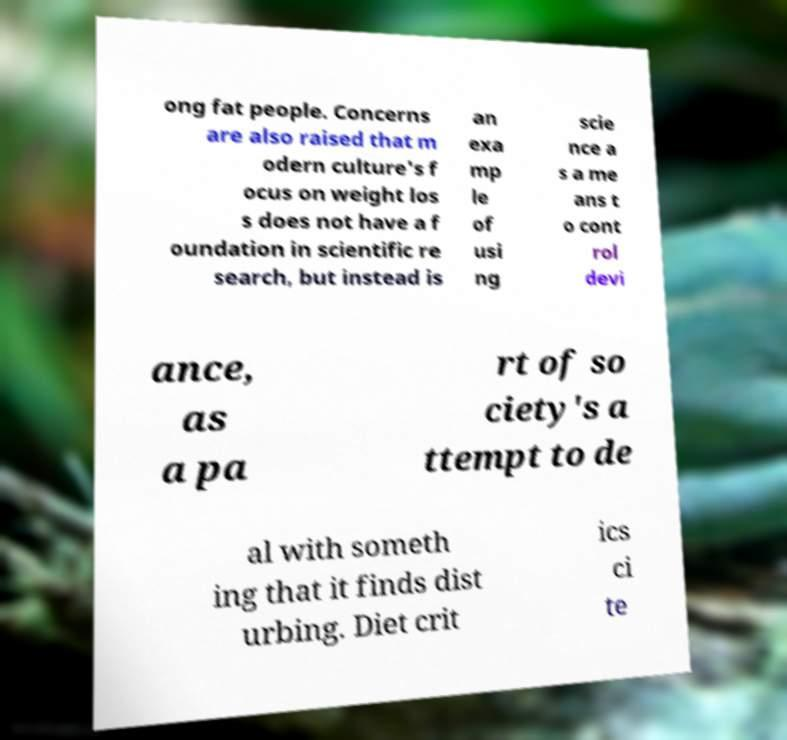Please read and relay the text visible in this image. What does it say? ong fat people. Concerns are also raised that m odern culture's f ocus on weight los s does not have a f oundation in scientific re search, but instead is an exa mp le of usi ng scie nce a s a me ans t o cont rol devi ance, as a pa rt of so ciety's a ttempt to de al with someth ing that it finds dist urbing. Diet crit ics ci te 